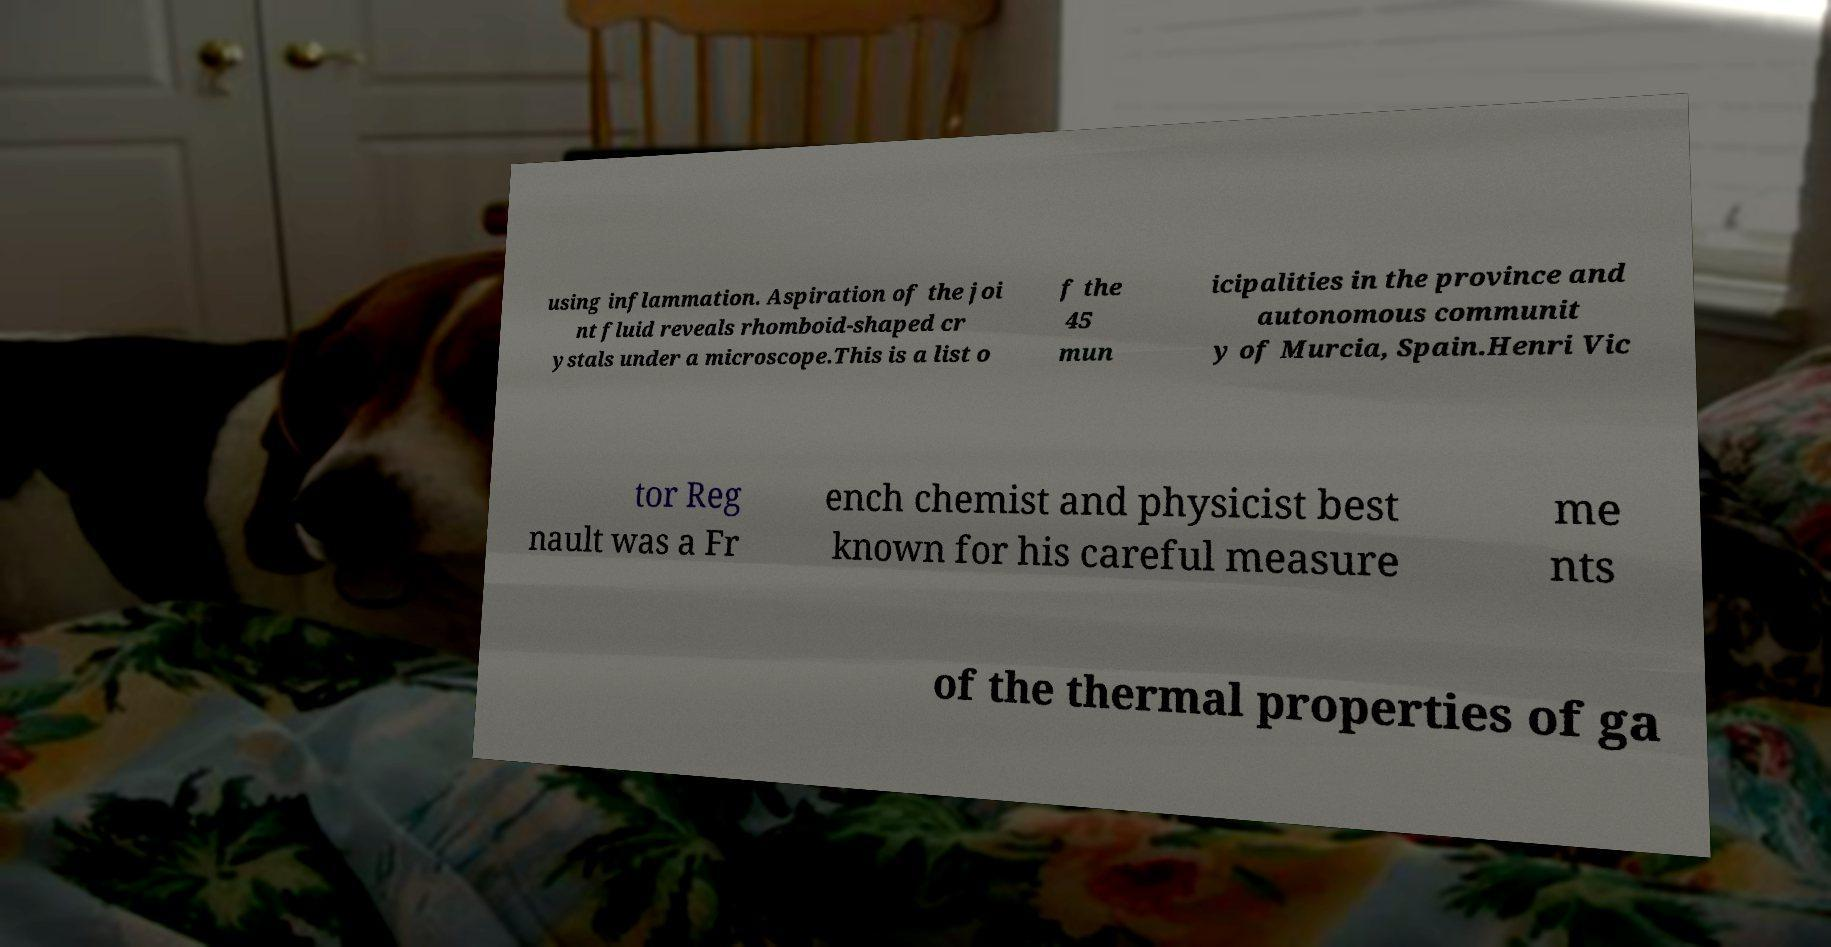Please read and relay the text visible in this image. What does it say? using inflammation. Aspiration of the joi nt fluid reveals rhomboid-shaped cr ystals under a microscope.This is a list o f the 45 mun icipalities in the province and autonomous communit y of Murcia, Spain.Henri Vic tor Reg nault was a Fr ench chemist and physicist best known for his careful measure me nts of the thermal properties of ga 